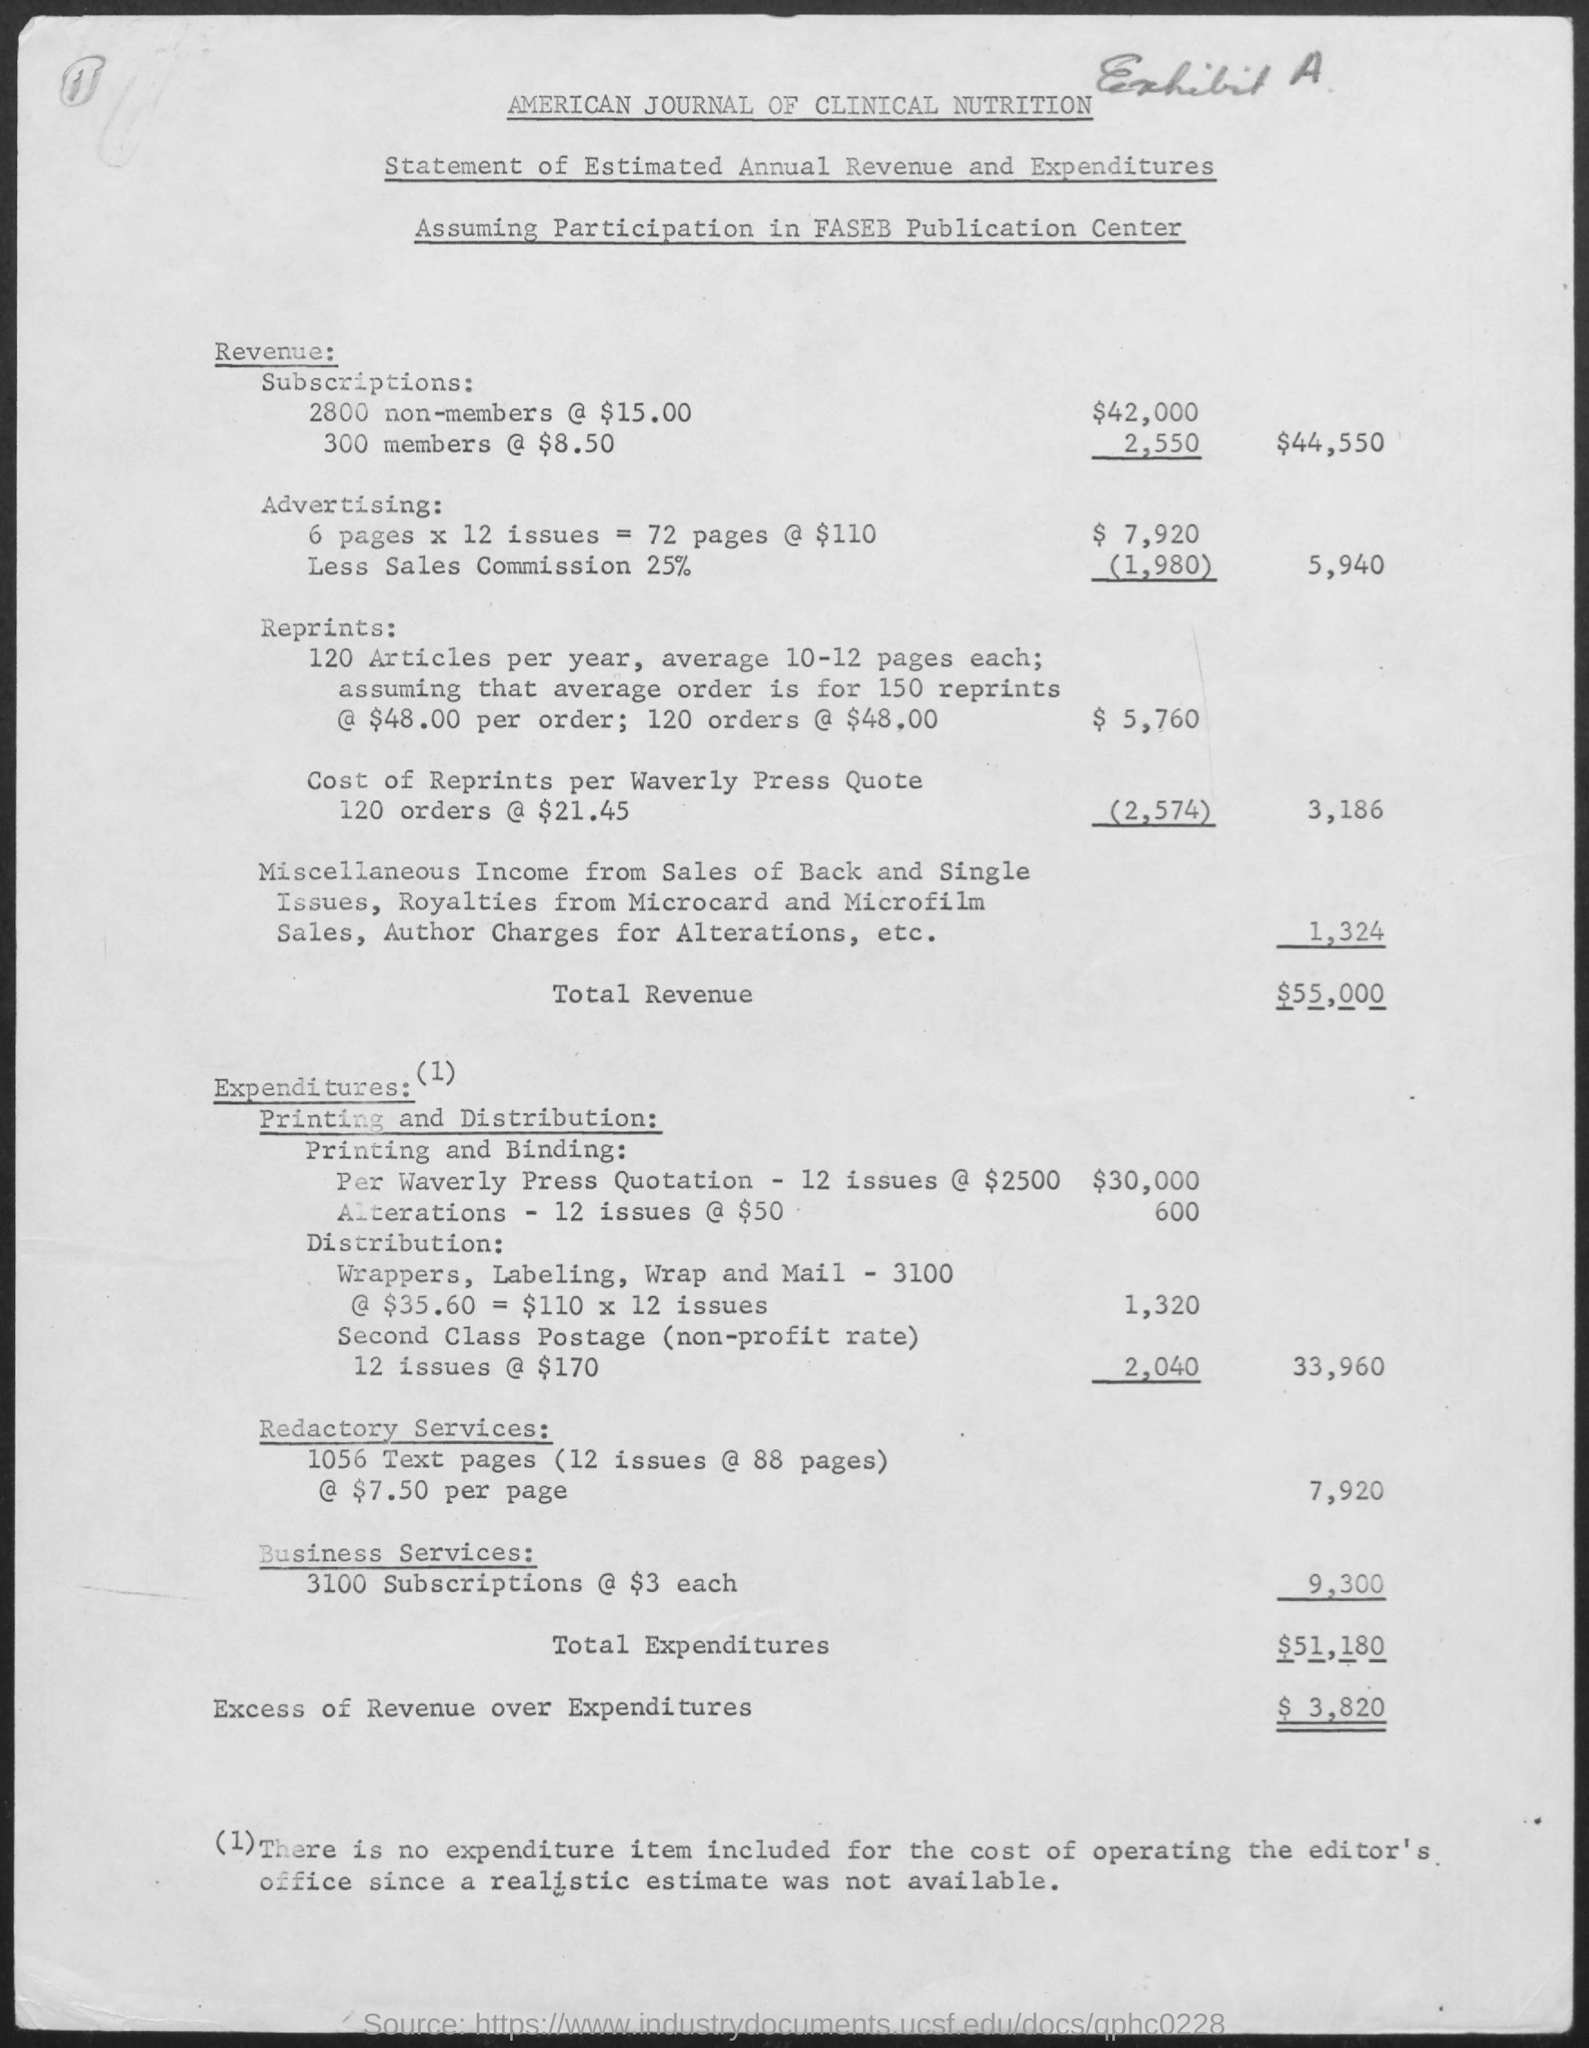What is the Total Revenue?
Keep it short and to the point. $55,000. What is the Total Expenditures?
Your answer should be very brief. 51,180. How much is excess of revenue over expenditures?
Ensure brevity in your answer.  3,280. 